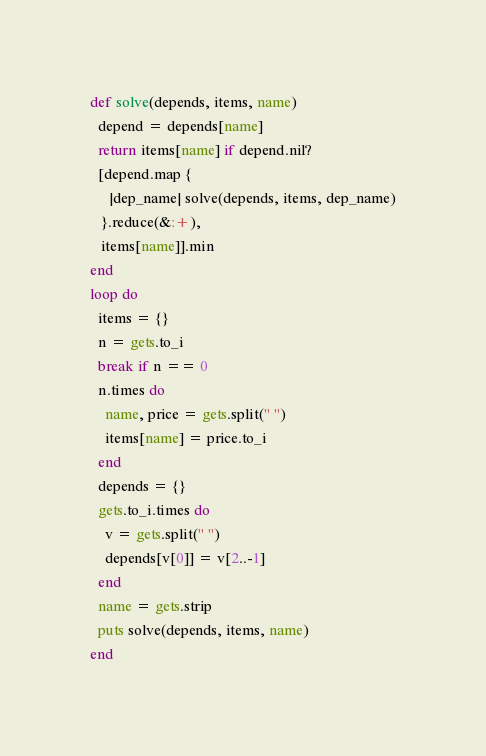Convert code to text. <code><loc_0><loc_0><loc_500><loc_500><_Ruby_>def solve(depends, items, name)
  depend = depends[name]
  return items[name] if depend.nil?
  [depend.map {
     |dep_name| solve(depends, items, dep_name)
   }.reduce(&:+),
   items[name]].min
end
loop do
  items = {}
  n = gets.to_i
  break if n == 0
  n.times do 
    name, price = gets.split(" ")
    items[name] = price.to_i
  end
  depends = {}
  gets.to_i.times do
    v = gets.split(" ")
    depends[v[0]] = v[2..-1]
  end
  name = gets.strip
  puts solve(depends, items, name)
end</code> 